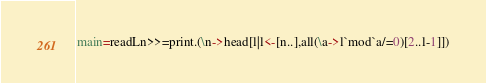<code> <loc_0><loc_0><loc_500><loc_500><_Haskell_>main=readLn>>=print.(\n->head[l|l<-[n..],all(\a->l`mod`a/=0)[2..l-1]])</code> 